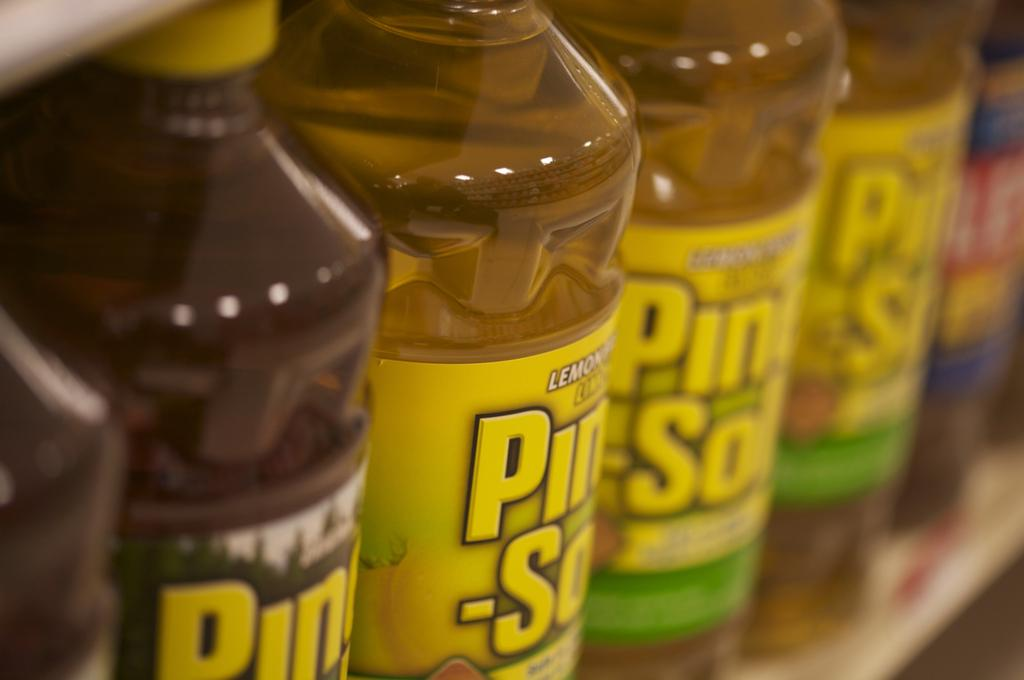<image>
Share a concise interpretation of the image provided. A row of different types of Pine Sol, light and dark. 